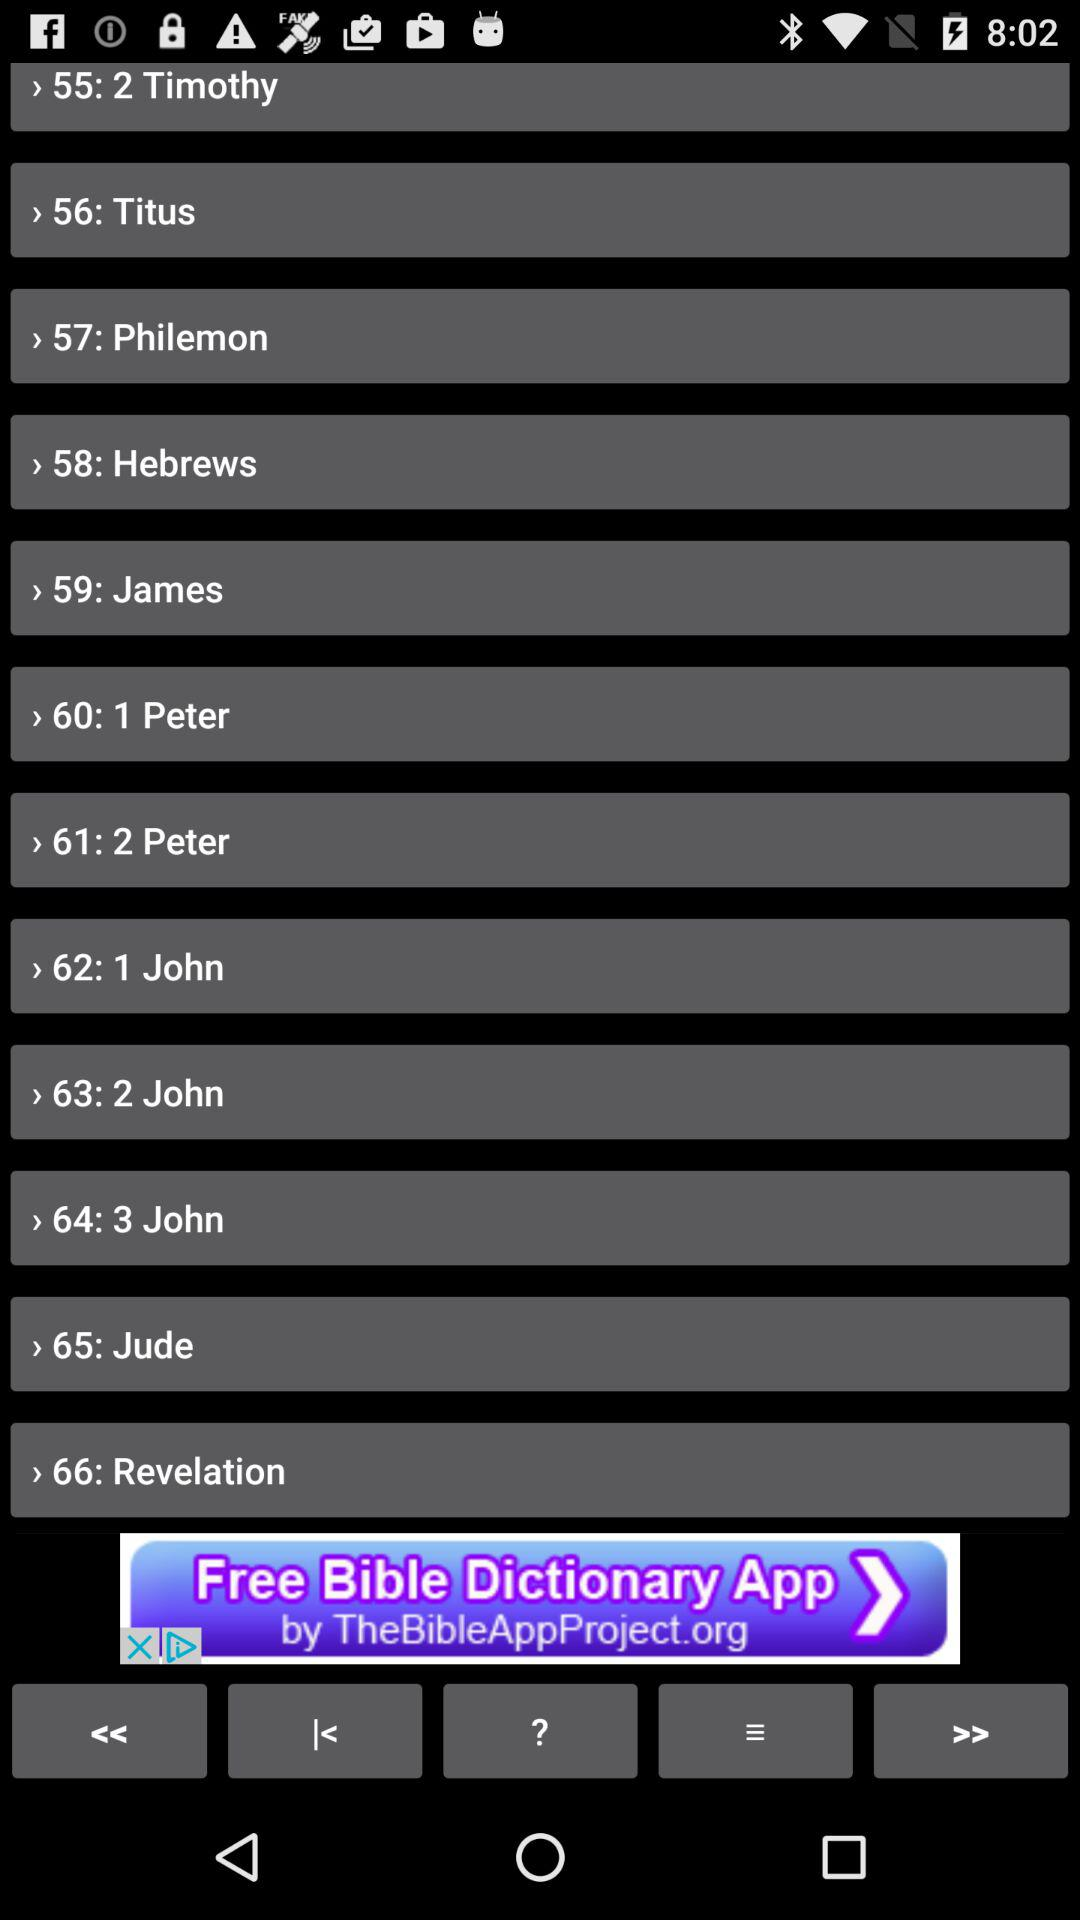What is the serial number of the "Titus"? The serial number of the "Titus" is 56. 